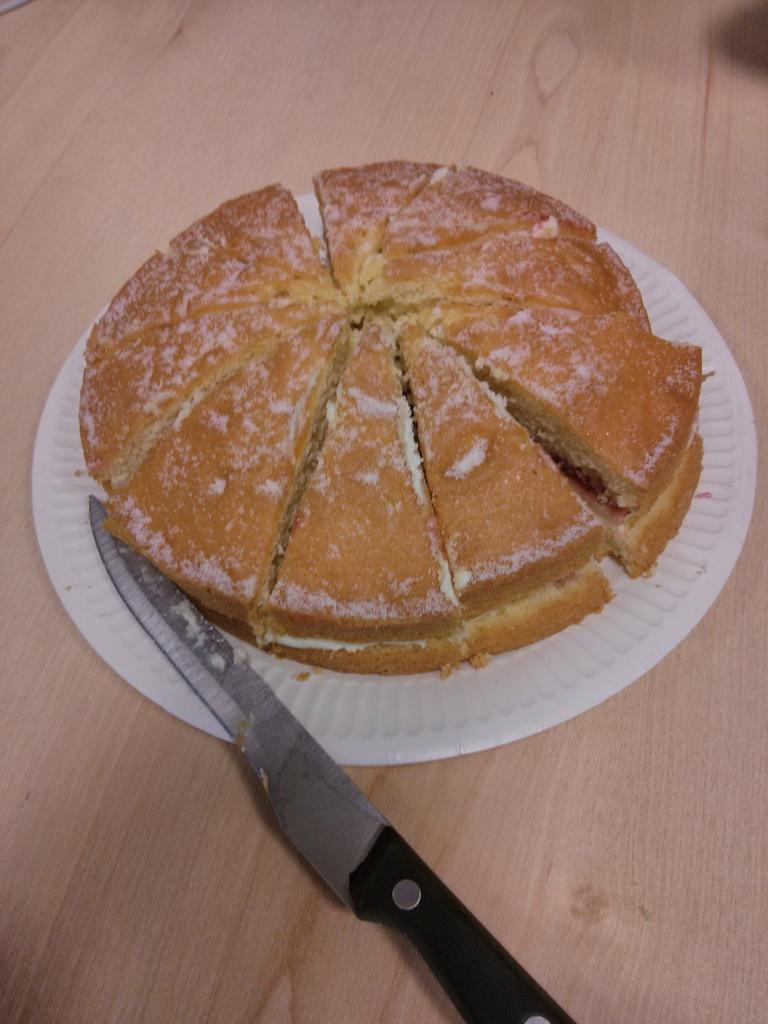What is on the plate in the image? There is food on a plate in the image. What utensil can be seen in the image? There is a knife on a surface in the image. What is the color of the surface the knife is on? The surface is brown in color. What direction is the sweater facing in the image? There is no sweater present in the image. 